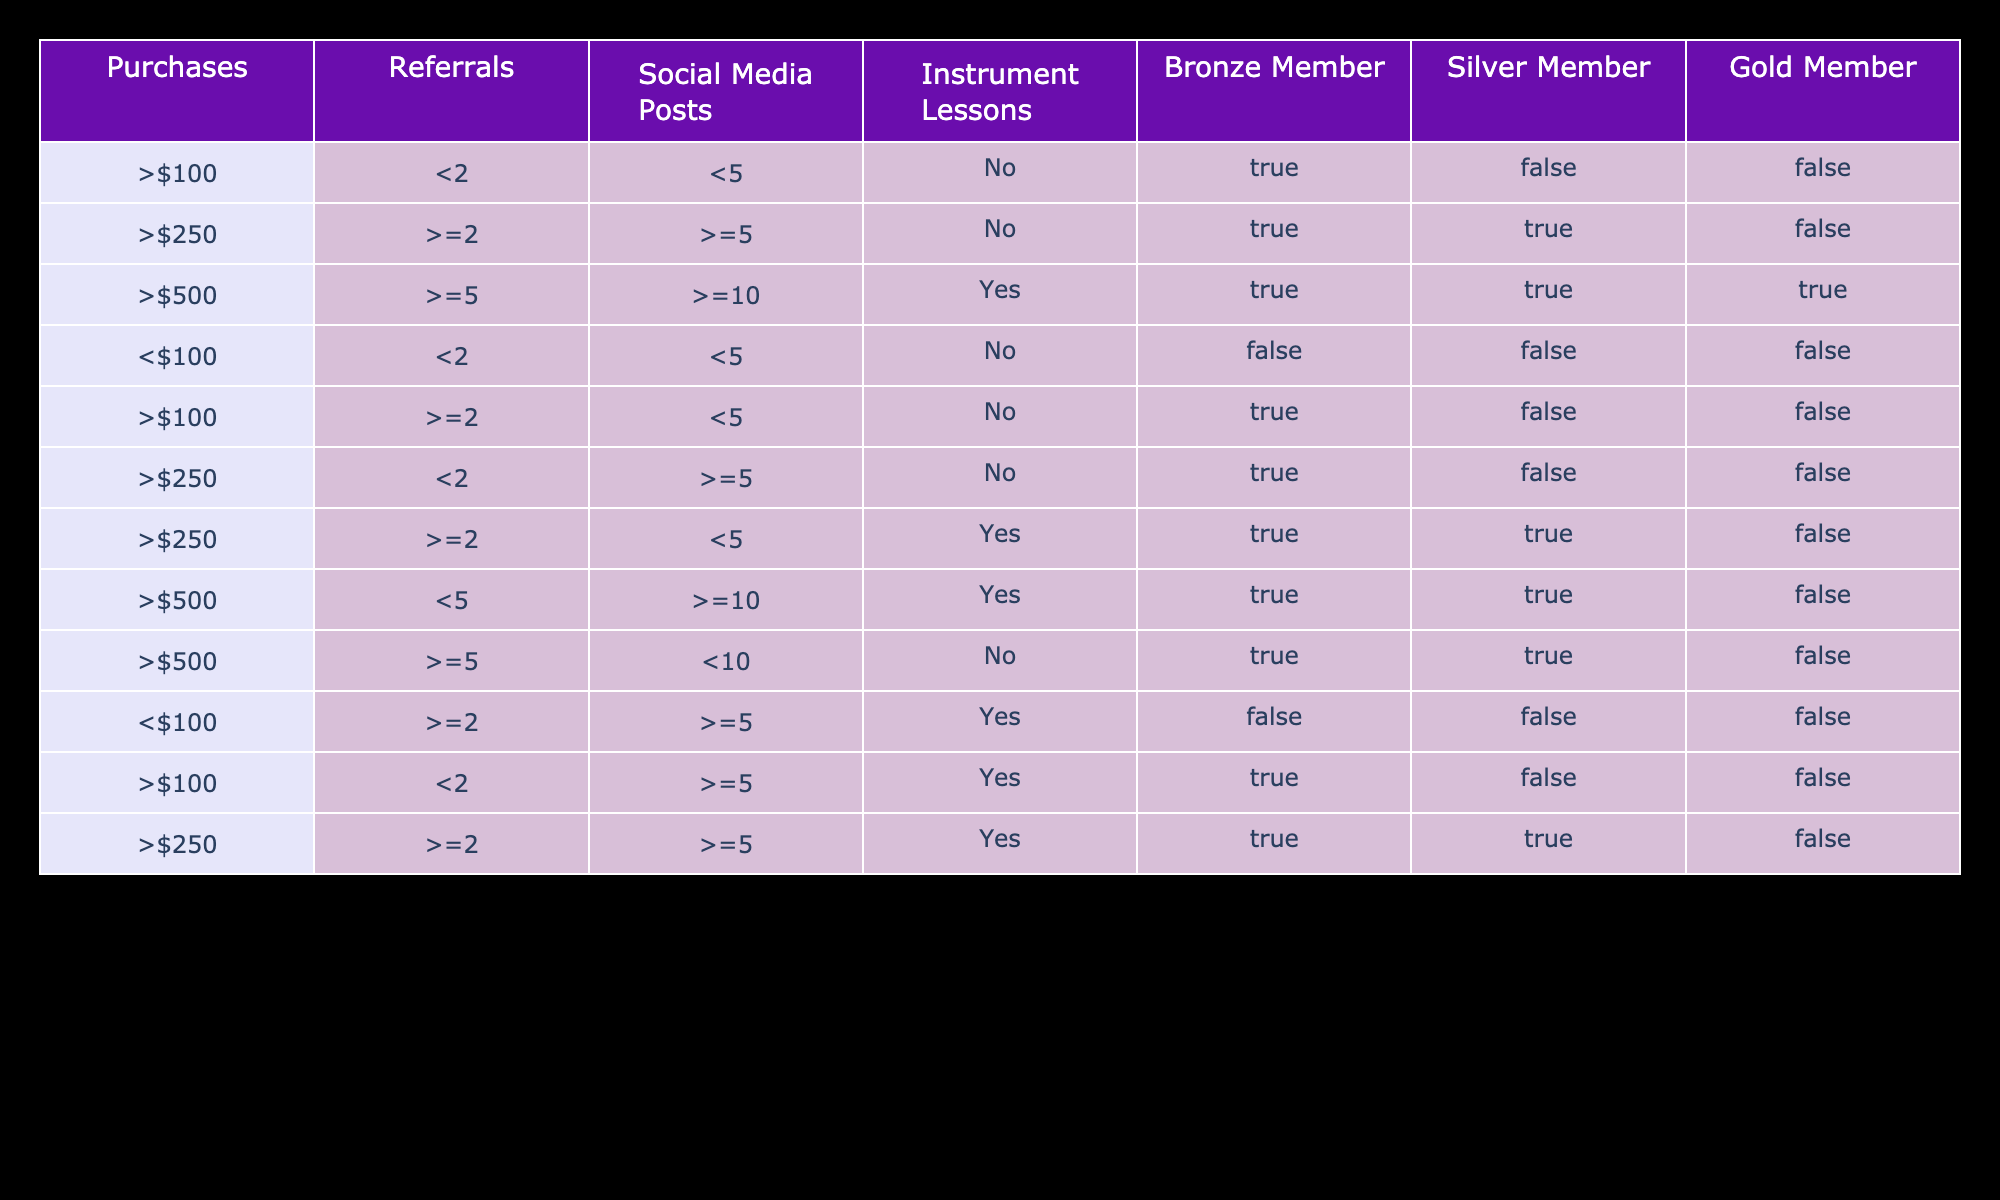What are the requirements to qualify for a Gold Member? To be a Gold Member, a person must have made purchases of $500 or more, made at least 5 referrals, posted 10 or more times on social media, and taken instrument lessons. This is found in the row with values for Bronze, Silver, and Gold Members all marked TRUE, corresponding to these purchase and activity levels.
Answer: Purchases of $500, >=5 referrals, >=10 social media posts, and instrument lessons taken How many members qualify for Silver membership based on different purchases? Silver membership is achieved with purchases of $250 or more and certain conditions about referrals, social media posts, and lessons. By analyzing the rows, members qualifying for Silver membership are those with values TRUE in the Silver column: one for purchases of $250 with >=2 referrals and >=5 posts, and another with $500. That equals two rows meeting these criteria.
Answer: 2 Is it possible to qualify for a Bronze Member without purchasing anything? To qualify for a Bronze Member, at least $100 in purchases must be made as stated in the rows, specifically those showing TRUE in the Bronze column. There are no entries that show a qualification for Bronze membership without fulfilling the purchase condition.
Answer: No Which purchase amount allows the most flexibility in qualifying for any membership? The question involves looking at the purchase amounts in rows where members qualify for Bronze, Silver, and Gold memberships. $250 qualifies a member for both Bronze and Silver memberships in multiple scenarios, while $500 meets all criteria across all levels. Since $250 allows entry into two member categories, it shows the most flexibility.
Answer: $250 If a customer has made 3 referrals and posted 7 times on social media, what membership can they qualify for? Based on the data, looking at rows that would fulfill the 3 referrals and 7 posts condition, $250 or more in purchases qualifies for Silver membership with >=2 referrals and >=5 posts. However, no row matches exactly; they would achieve at least Silver due to these figures.
Answer: Silver Member Can someone who spent $100 and made 6 social media posts qualify for any membership? From the table, the row with $100 purchases requires less than 5 social media posts to verify Bronze membership. However, with 6 posts, no membership qualifies because this exceeds conditions for Bronze. This means they won't qualify for any membership levels given the purchase amount and social media activity.
Answer: No What's the total number of people who took instrument lessons for Gold membership? The only row that confirms instrument lessons required for Gold membership also states $500 is required alongside other conditions. Since there is only one participant qualifying as Gold who took lessons, check the corresponding memberships qualify. Only 1 person meets this condition exactly in the data here.
Answer: 1 What is the minimum number of referrals needed for any membership? Checking all rows, referrals needed are at least 2 for Bronze and 2 for Silver, but Gold requires at least 5. The minimum number showing each condition in the respective columns allows for Bronze membership when offset against the lowest purchases of above $100. Thus the minimum possible is 2 referrals.
Answer: 2 If someone qualifies for Silver, do they also qualify for Bronze? Qualifying for Silver requires at least $250 in purchases and meeting criteria for referrals and social media posts. As all conditions for Gold and Silver intersect with Bronze including purchase and activity levels, therefore qualifying for Silver indeed gives them qualification status for Bronze membership too based on the criteria given in each row.
Answer: Yes 